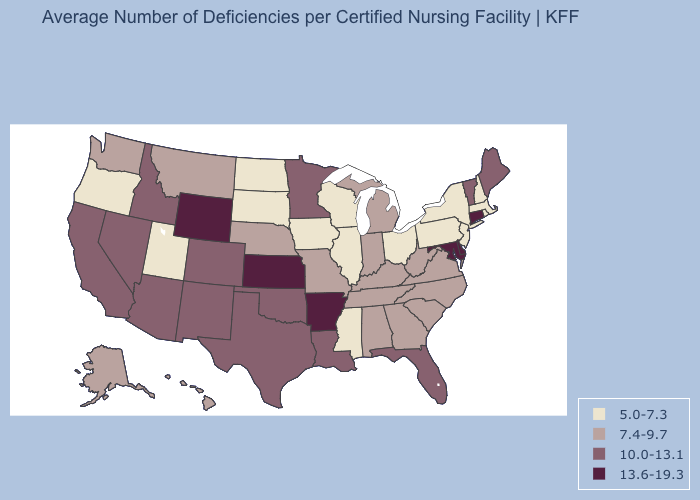What is the value of Arizona?
Quick response, please. 10.0-13.1. Does Utah have the lowest value in the West?
Be succinct. Yes. Name the states that have a value in the range 10.0-13.1?
Give a very brief answer. Arizona, California, Colorado, Florida, Idaho, Louisiana, Maine, Minnesota, Nevada, New Mexico, Oklahoma, Texas, Vermont. Name the states that have a value in the range 5.0-7.3?
Short answer required. Illinois, Iowa, Massachusetts, Mississippi, New Hampshire, New Jersey, New York, North Dakota, Ohio, Oregon, Pennsylvania, Rhode Island, South Dakota, Utah, Wisconsin. Is the legend a continuous bar?
Quick response, please. No. What is the value of Nebraska?
Write a very short answer. 7.4-9.7. Does North Carolina have the same value as Indiana?
Concise answer only. Yes. What is the highest value in states that border Missouri?
Keep it brief. 13.6-19.3. What is the value of West Virginia?
Write a very short answer. 7.4-9.7. Which states have the lowest value in the Northeast?
Be succinct. Massachusetts, New Hampshire, New Jersey, New York, Pennsylvania, Rhode Island. Does Rhode Island have the lowest value in the Northeast?
Keep it brief. Yes. Does Alaska have the highest value in the USA?
Write a very short answer. No. What is the lowest value in the South?
Concise answer only. 5.0-7.3. What is the lowest value in the South?
Short answer required. 5.0-7.3. Name the states that have a value in the range 10.0-13.1?
Write a very short answer. Arizona, California, Colorado, Florida, Idaho, Louisiana, Maine, Minnesota, Nevada, New Mexico, Oklahoma, Texas, Vermont. 